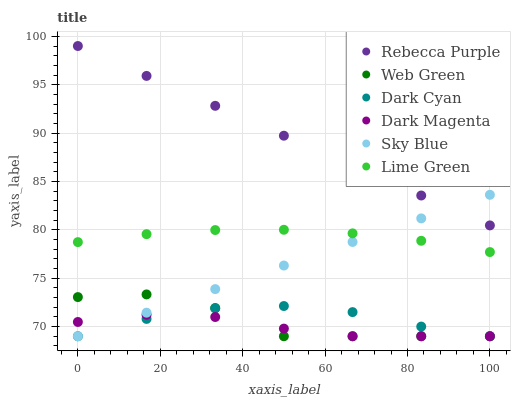Does Dark Magenta have the minimum area under the curve?
Answer yes or no. Yes. Does Rebecca Purple have the maximum area under the curve?
Answer yes or no. Yes. Does Web Green have the minimum area under the curve?
Answer yes or no. No. Does Web Green have the maximum area under the curve?
Answer yes or no. No. Is Rebecca Purple the smoothest?
Answer yes or no. Yes. Is Web Green the roughest?
Answer yes or no. Yes. Is Web Green the smoothest?
Answer yes or no. No. Is Rebecca Purple the roughest?
Answer yes or no. No. Does Dark Magenta have the lowest value?
Answer yes or no. Yes. Does Rebecca Purple have the lowest value?
Answer yes or no. No. Does Rebecca Purple have the highest value?
Answer yes or no. Yes. Does Web Green have the highest value?
Answer yes or no. No. Is Dark Cyan less than Lime Green?
Answer yes or no. Yes. Is Rebecca Purple greater than Dark Cyan?
Answer yes or no. Yes. Does Web Green intersect Sky Blue?
Answer yes or no. Yes. Is Web Green less than Sky Blue?
Answer yes or no. No. Is Web Green greater than Sky Blue?
Answer yes or no. No. Does Dark Cyan intersect Lime Green?
Answer yes or no. No. 